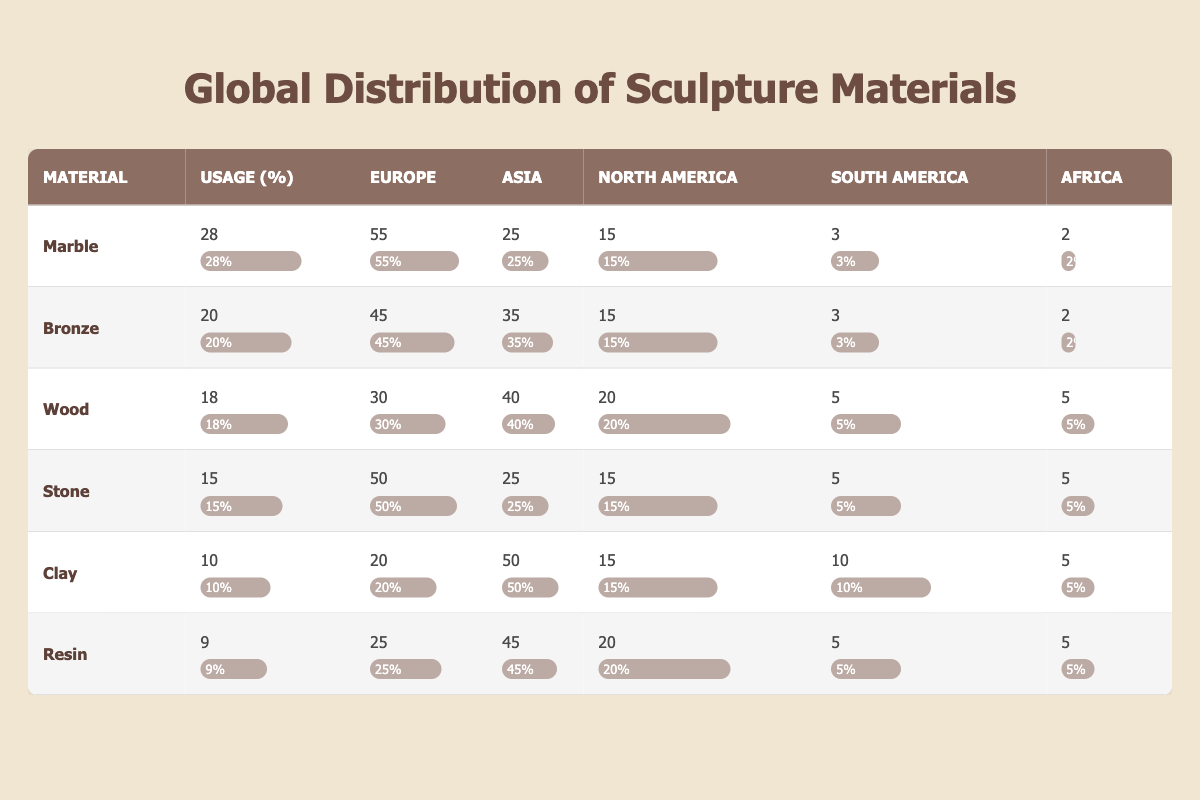What is the usage percentage of bronze as a sculpture material? The usage percentage for bronze is listed directly in the table under the "Usage (%)" column, where it states 20%.
Answer: 20% Which material has the highest usage percentage? By comparing the "Usage (%)" column for all materials, marble has the highest percentage at 28%.
Answer: Marble What percentage of sculpture materials is wood in Europe? Referring to the "Europe" column under wood, it shows 30%.
Answer: 30% Is the percentage of resin usage higher than that of clay? The usage percentage for resin is 9%, while for clay it is 10%. Since 9% is less than 10%, the statement is false.
Answer: No What is the total percentage of sculpture material usage in South America? Adding the percentages for all materials in South America: 3 + 3 + 5 + 5 + 10 + 5 = 31%.
Answer: 31% If we consider Asia's percentages, which material has the highest usage? Looking at the "Asia" column, clay has the highest percentage with 50%.
Answer: Clay What is the difference in the percentage of marble and stone usage? The difference can be calculated by subtracting the usage of stone (15%) from marble (28%), which leads to 28% - 15% = 13%.
Answer: 13% Is it true that Africa has a higher percentage of stone usage compared to clay? Stone has a usage percentage of 5% in Africa, while clay has a usage percentage of 5% as well. Thus, both are equal, making the statement false.
Answer: No What is the average percentage of sculpture materials used in North America? To find the average for North America, sum the percentages: 15 + 15 + 20 + 15 + 15 + 20 = 100, then divide by 6 (the number of materials), results in an average of 16.67%.
Answer: 16.67% 